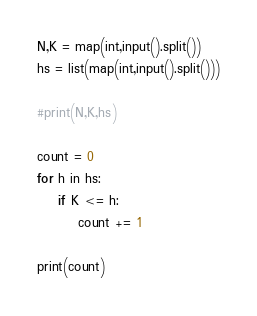Convert code to text. <code><loc_0><loc_0><loc_500><loc_500><_Python_>N,K = map(int,input().split())
hs = list(map(int,input().split()))
	
#print(N,K,hs)

count = 0
for h in hs:
	if K <= h:
		count += 1
		
print(count)</code> 